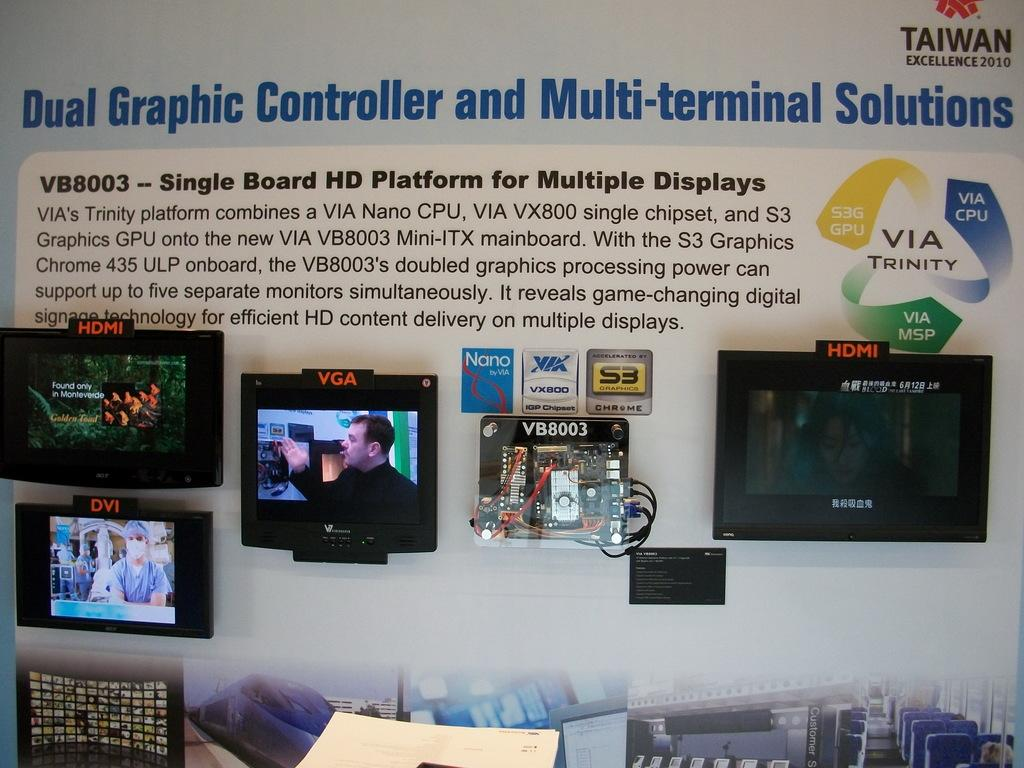<image>
Summarize the visual content of the image. a multi terminal message above a paragraph of info 